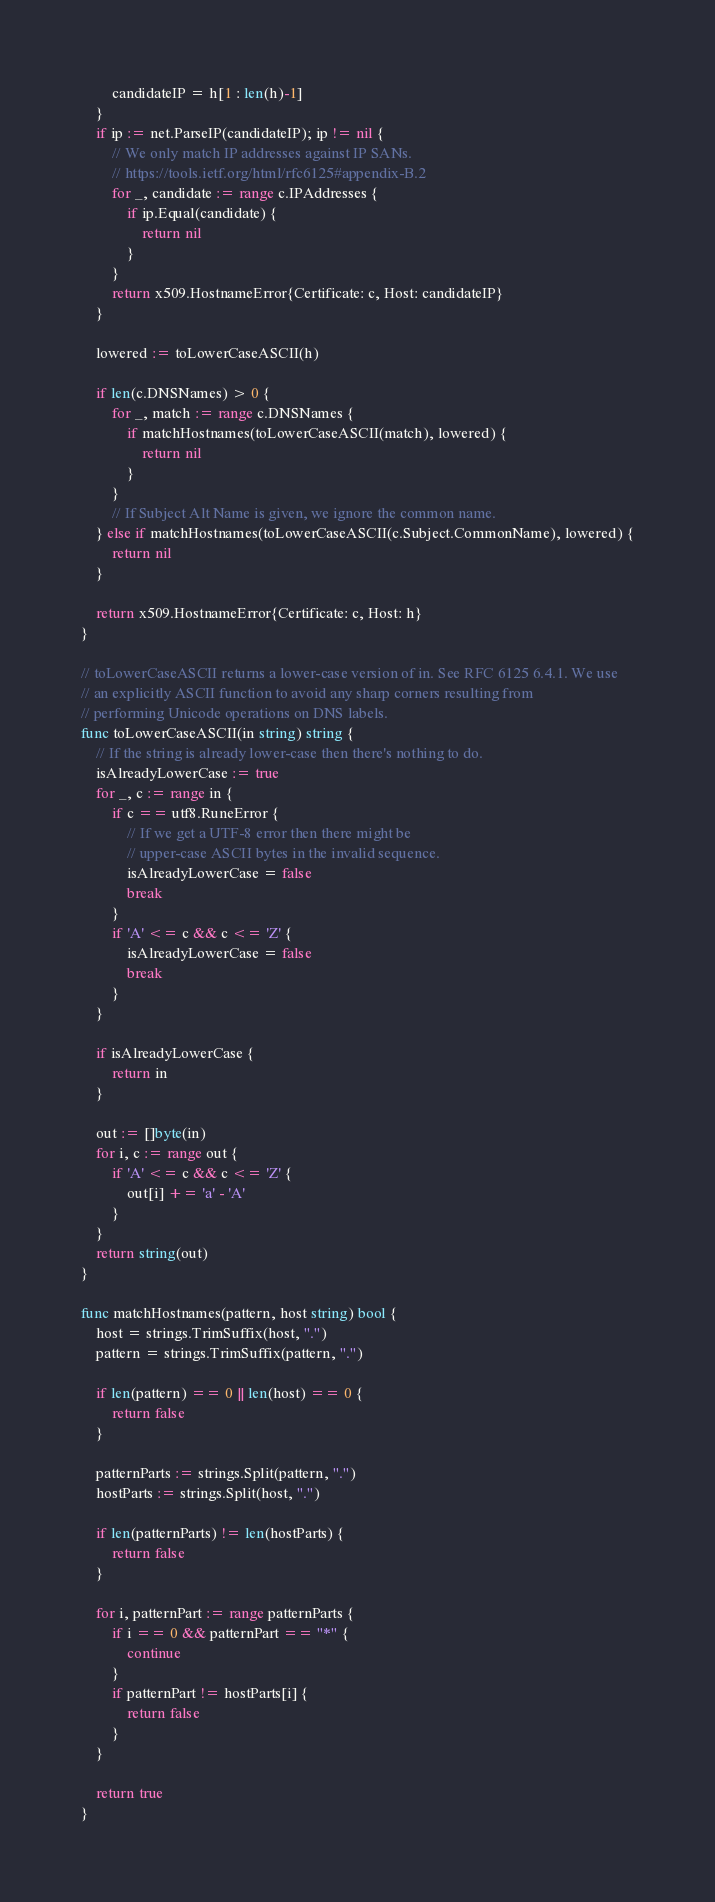<code> <loc_0><loc_0><loc_500><loc_500><_Go_>		candidateIP = h[1 : len(h)-1]
	}
	if ip := net.ParseIP(candidateIP); ip != nil {
		// We only match IP addresses against IP SANs.
		// https://tools.ietf.org/html/rfc6125#appendix-B.2
		for _, candidate := range c.IPAddresses {
			if ip.Equal(candidate) {
				return nil
			}
		}
		return x509.HostnameError{Certificate: c, Host: candidateIP}
	}

	lowered := toLowerCaseASCII(h)

	if len(c.DNSNames) > 0 {
		for _, match := range c.DNSNames {
			if matchHostnames(toLowerCaseASCII(match), lowered) {
				return nil
			}
		}
		// If Subject Alt Name is given, we ignore the common name.
	} else if matchHostnames(toLowerCaseASCII(c.Subject.CommonName), lowered) {
		return nil
	}

	return x509.HostnameError{Certificate: c, Host: h}
}

// toLowerCaseASCII returns a lower-case version of in. See RFC 6125 6.4.1. We use
// an explicitly ASCII function to avoid any sharp corners resulting from
// performing Unicode operations on DNS labels.
func toLowerCaseASCII(in string) string {
	// If the string is already lower-case then there's nothing to do.
	isAlreadyLowerCase := true
	for _, c := range in {
		if c == utf8.RuneError {
			// If we get a UTF-8 error then there might be
			// upper-case ASCII bytes in the invalid sequence.
			isAlreadyLowerCase = false
			break
		}
		if 'A' <= c && c <= 'Z' {
			isAlreadyLowerCase = false
			break
		}
	}

	if isAlreadyLowerCase {
		return in
	}

	out := []byte(in)
	for i, c := range out {
		if 'A' <= c && c <= 'Z' {
			out[i] += 'a' - 'A'
		}
	}
	return string(out)
}

func matchHostnames(pattern, host string) bool {
	host = strings.TrimSuffix(host, ".")
	pattern = strings.TrimSuffix(pattern, ".")

	if len(pattern) == 0 || len(host) == 0 {
		return false
	}

	patternParts := strings.Split(pattern, ".")
	hostParts := strings.Split(host, ".")

	if len(patternParts) != len(hostParts) {
		return false
	}

	for i, patternPart := range patternParts {
		if i == 0 && patternPart == "*" {
			continue
		}
		if patternPart != hostParts[i] {
			return false
		}
	}

	return true
}
</code> 